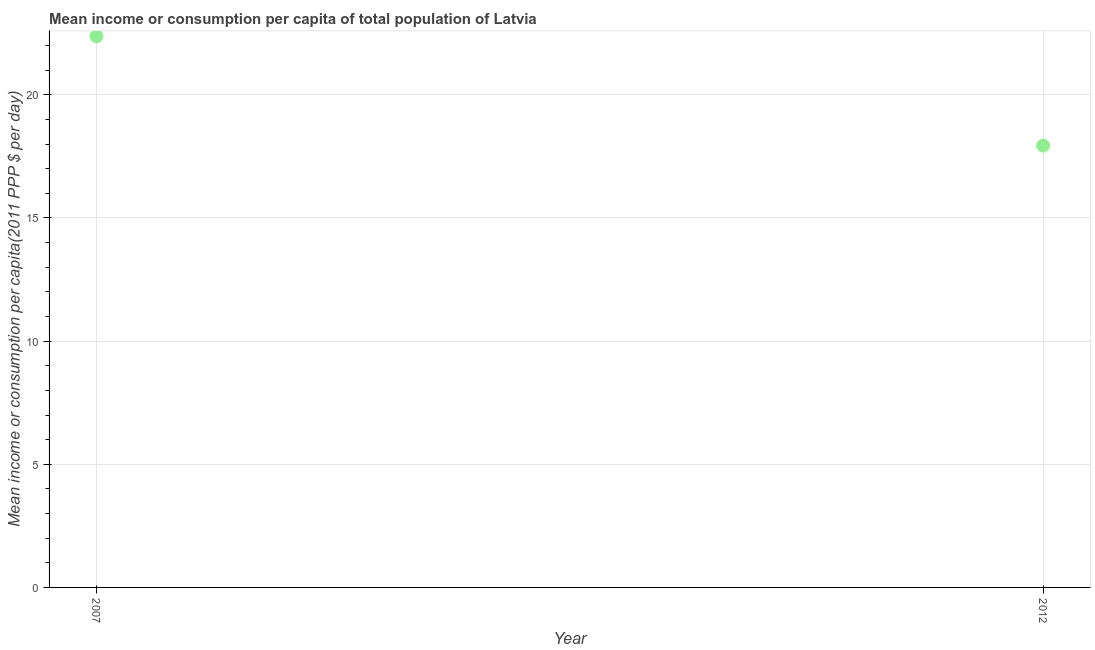What is the mean income or consumption in 2012?
Offer a terse response. 17.94. Across all years, what is the maximum mean income or consumption?
Keep it short and to the point. 22.38. Across all years, what is the minimum mean income or consumption?
Provide a succinct answer. 17.94. What is the sum of the mean income or consumption?
Keep it short and to the point. 40.31. What is the difference between the mean income or consumption in 2007 and 2012?
Make the answer very short. 4.44. What is the average mean income or consumption per year?
Give a very brief answer. 20.16. What is the median mean income or consumption?
Keep it short and to the point. 20.16. In how many years, is the mean income or consumption greater than 20 $?
Offer a very short reply. 1. What is the ratio of the mean income or consumption in 2007 to that in 2012?
Provide a succinct answer. 1.25. In how many years, is the mean income or consumption greater than the average mean income or consumption taken over all years?
Offer a terse response. 1. Does the mean income or consumption monotonically increase over the years?
Make the answer very short. No. How many dotlines are there?
Keep it short and to the point. 1. What is the title of the graph?
Offer a very short reply. Mean income or consumption per capita of total population of Latvia. What is the label or title of the Y-axis?
Your answer should be compact. Mean income or consumption per capita(2011 PPP $ per day). What is the Mean income or consumption per capita(2011 PPP $ per day) in 2007?
Provide a succinct answer. 22.38. What is the Mean income or consumption per capita(2011 PPP $ per day) in 2012?
Your answer should be very brief. 17.94. What is the difference between the Mean income or consumption per capita(2011 PPP $ per day) in 2007 and 2012?
Your answer should be compact. 4.44. What is the ratio of the Mean income or consumption per capita(2011 PPP $ per day) in 2007 to that in 2012?
Ensure brevity in your answer.  1.25. 